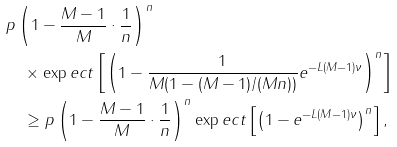Convert formula to latex. <formula><loc_0><loc_0><loc_500><loc_500>& p \left ( 1 - \frac { M - 1 } { M } \cdot \frac { 1 } { n } \right ) ^ { n } \\ & \quad \times \exp e c t \left [ \left ( 1 - \frac { 1 } { M ( 1 - ( M - 1 ) / ( M n ) ) } e ^ { - L ( M - 1 ) \nu } \right ) ^ { n } \right ] \\ & \quad \geq p \left ( 1 - \frac { M - 1 } { M } \cdot \frac { 1 } { n } \right ) ^ { n } \exp e c t \left [ \left ( 1 - e ^ { - L ( M - 1 ) \nu } \right ) ^ { n } \right ] ,</formula> 